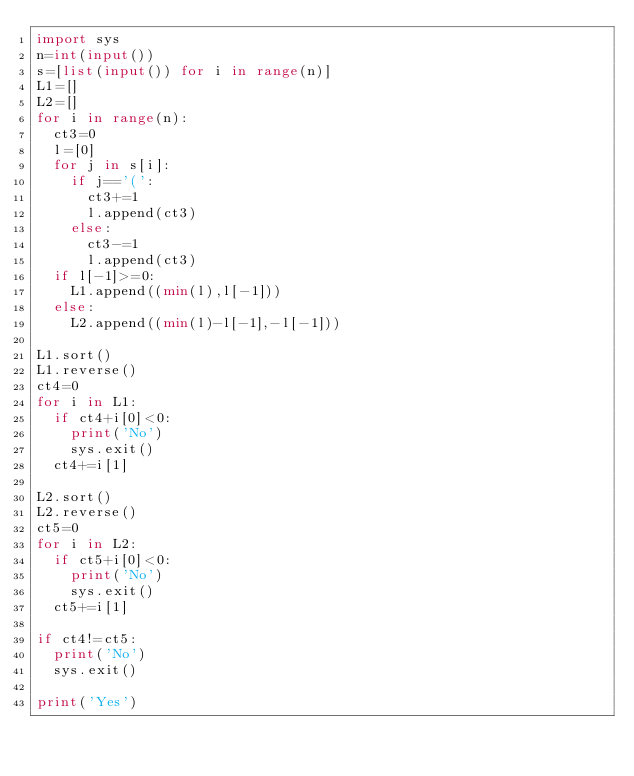<code> <loc_0><loc_0><loc_500><loc_500><_Python_>import sys
n=int(input())
s=[list(input()) for i in range(n)]
L1=[]
L2=[]
for i in range(n):
  ct3=0
  l=[0]
  for j in s[i]:
    if j=='(':
      ct3+=1
      l.append(ct3)
    else:
      ct3-=1
      l.append(ct3)
  if l[-1]>=0:
    L1.append((min(l),l[-1]))
  else:
    L2.append((min(l)-l[-1],-l[-1]))

L1.sort()
L1.reverse()
ct4=0
for i in L1:
  if ct4+i[0]<0:
    print('No')
    sys.exit()
  ct4+=i[1]

L2.sort()
L2.reverse()
ct5=0
for i in L2:
  if ct5+i[0]<0:
    print('No')
    sys.exit()
  ct5+=i[1]

if ct4!=ct5:
  print('No')
  sys.exit()

print('Yes')</code> 